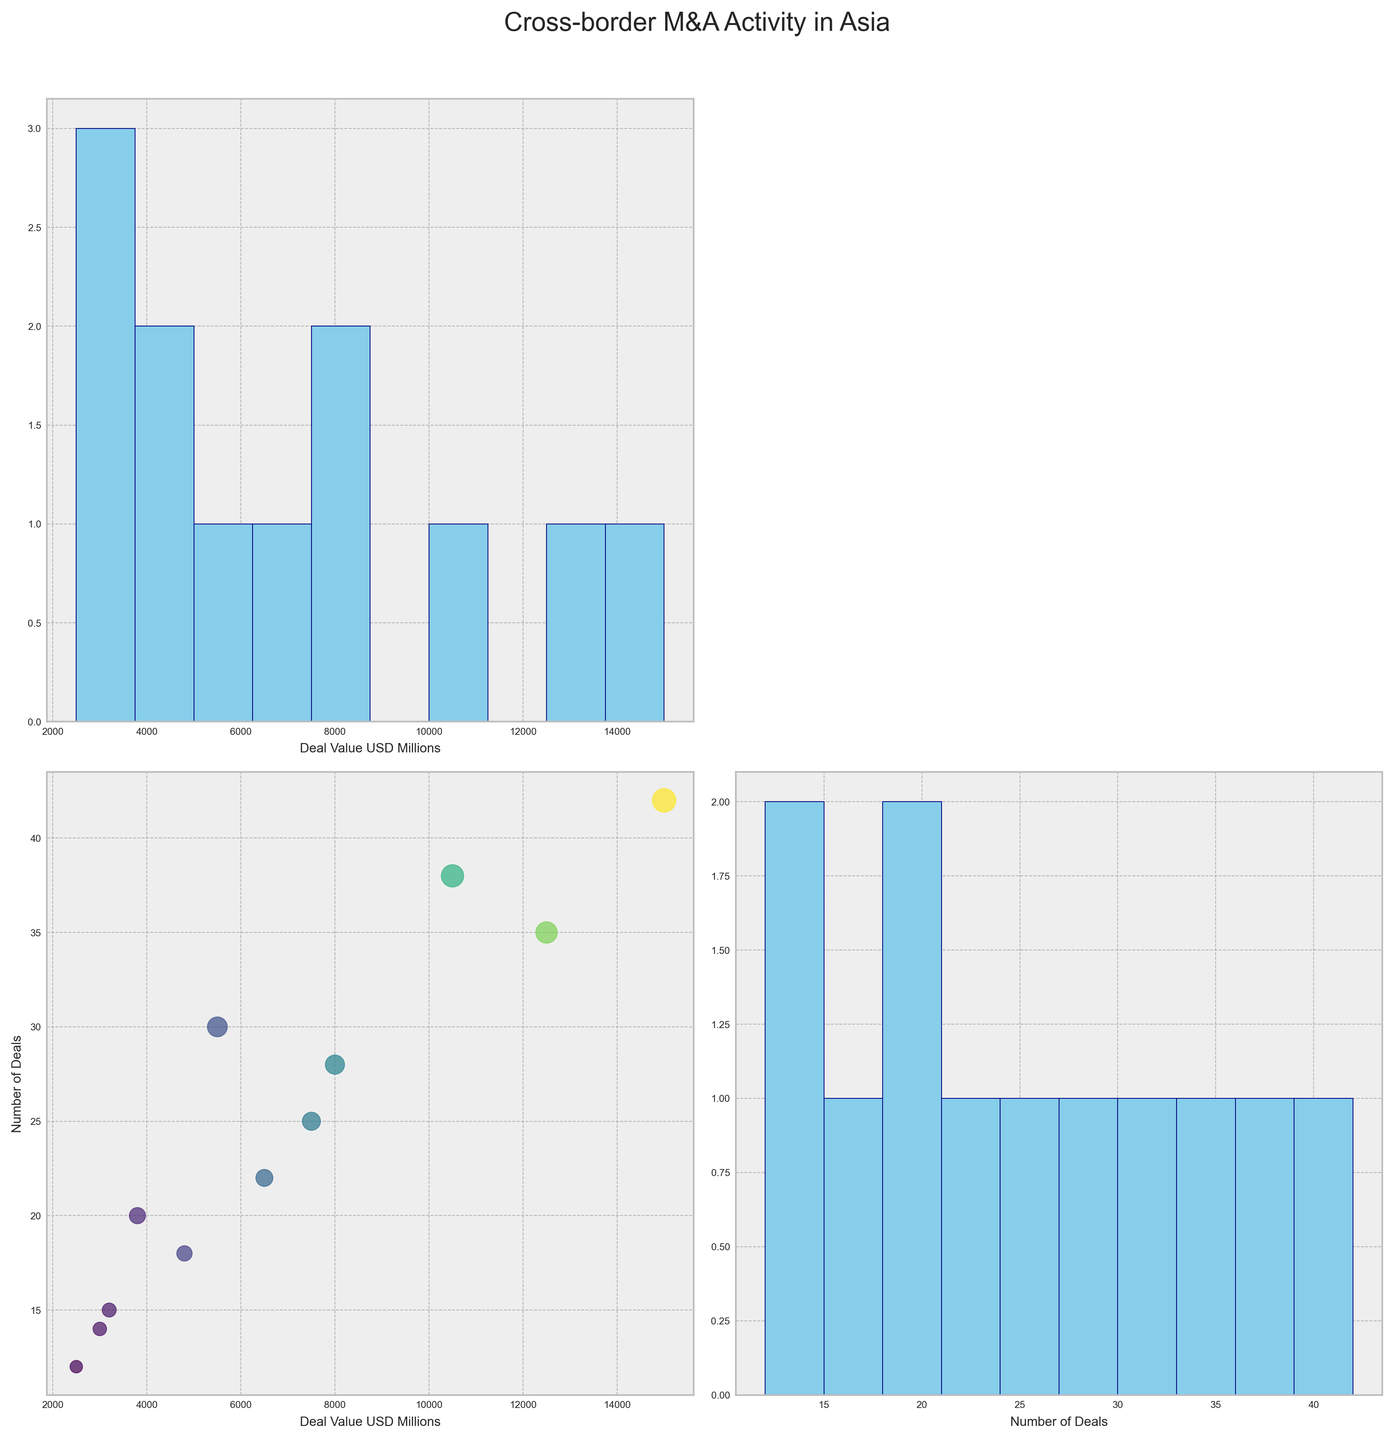What's the title of the scatterplot matrix? The title of the scatterplot matrix is displayed at the top of the figure.
Answer: Cross-border M&A Activity in Asia How many countries are involved in the dataset and hence plotted in the scatterplot matrix? The country labels annotated in the scatterplot matrix can be counted.
Answer: 12 Which country has the highest deal value and how much is it? By looking at the scatterplot where the 'Deal Value USD Millions' are plotted on the y-axis, the highest deal value can be identified.
Answer: China, 15000 million USD How many deals were involved for Taiwan and how is it reflected on the scatter plot? The number of deals can be read from the labels on the x-axis. It can also be estimated by the size of the bubble for Taiwan in the scatterplot.
Answer: 30 deals Which sector had the most number of deals, and how is it represented in the scatterplot? The scatterplot and the data suggest that the technology sector (corresponding with the highest number of deals and deal value) would be represented by China.
Answer: Technology, represented by China Which countries have similar deal values and number of deals based on their proximity in the scatterplot? By comparing the coordinates of the scatter points, countries that are plotted close to each other can be identified as having similar values.
Answer: Indonesia and Thailand How does the number of deals correlate with the deal value among the plotted countries? By observing the scatterplot of Number of Deals vs. Deal Value USD Millions, one can determine the correlation between number of deals and deal values through the pattern of points.
Answer: Generally, there is a positive correlation Which country had the lowest number of deals and what was its sector? Looking at the scatterplot where the x-axis represents the number of deals, the country with the smallest bubble on the far left can be identified.
Answer: Philippines, E-commerce Compare the deal values for India and Japan and determine which country had a higher deal value. By looking at the scatterplot of each country's position on the y-axis for Deal Value, compare their heights.
Answer: India had a lower value than Japan Between Hong Kong and Singapore, which country had more deals and how can you tell? Identifying the positions of Hong Kong and Singapore on the x-axis of the scatterplot for the Number of Deals enables the comparison.
Answer: Hong Kong had more deals 